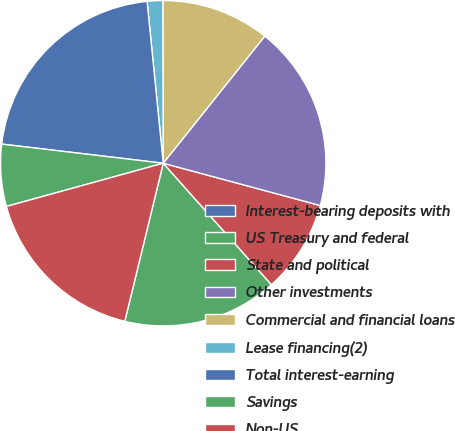Convert chart to OTSL. <chart><loc_0><loc_0><loc_500><loc_500><pie_chart><fcel>Interest-bearing deposits with<fcel>US Treasury and federal<fcel>State and political<fcel>Other investments<fcel>Commercial and financial loans<fcel>Lease financing(2)<fcel>Total interest-earning<fcel>Savings<fcel>Non-US<nl><fcel>0.0%<fcel>15.38%<fcel>9.23%<fcel>18.46%<fcel>10.77%<fcel>1.54%<fcel>21.54%<fcel>6.16%<fcel>16.92%<nl></chart> 